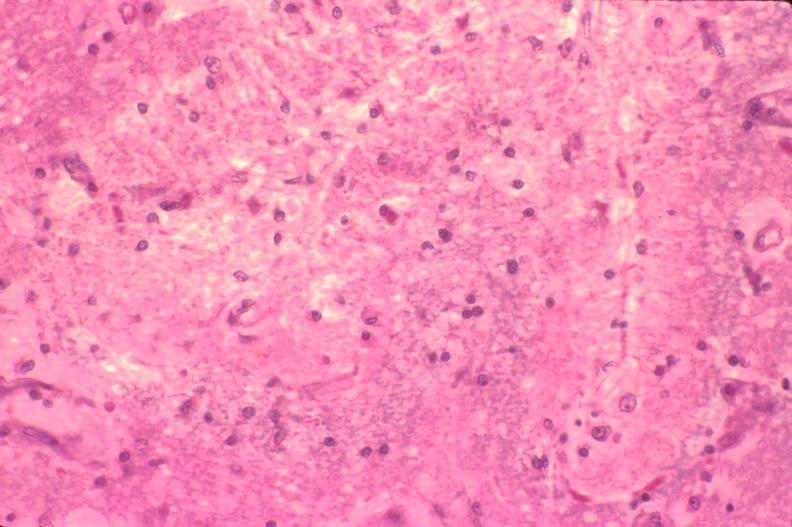does tumor show brain, old infarcts, embolic?
Answer the question using a single word or phrase. No 